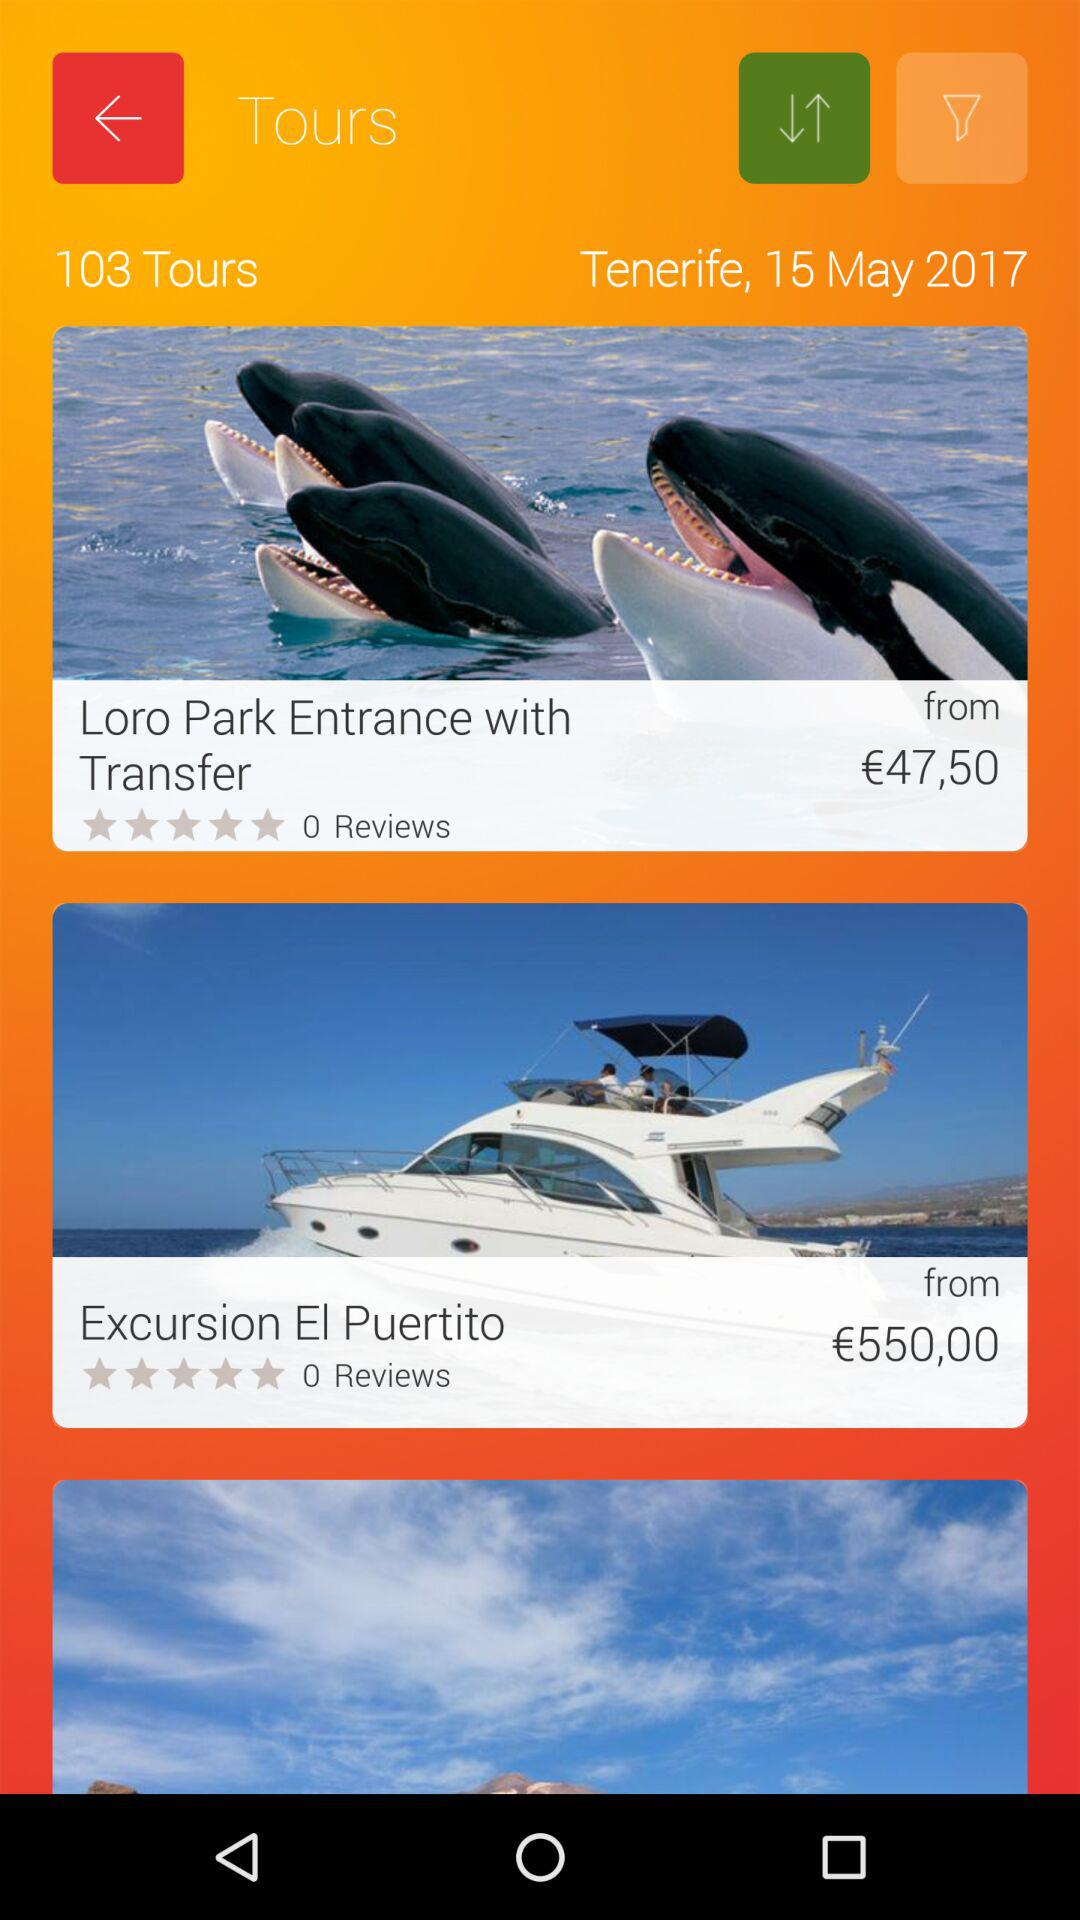How many reviews are there for "Excursion El Puertito"? There are 0 reviews. 